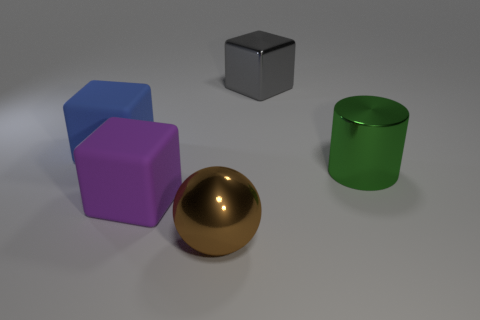Are there the same number of large purple matte things that are in front of the big brown metallic thing and large green shiny things?
Your response must be concise. No. Is there anything else that has the same material as the purple block?
Ensure brevity in your answer.  Yes. What number of small objects are either cyan rubber things or blocks?
Provide a short and direct response. 0. Do the large cube that is on the right side of the large purple matte thing and the cylinder have the same material?
Your answer should be very brief. Yes. Are there the same number of large gray cylinders and cylinders?
Your response must be concise. No. What is the material of the block in front of the big metal object to the right of the gray cube?
Your answer should be compact. Rubber. What number of green metallic objects have the same shape as the blue matte object?
Provide a succinct answer. 0. There is a matte block that is behind the metal thing to the right of the large cube that is to the right of the brown metal thing; what is its size?
Provide a succinct answer. Large. How many brown things are things or shiny cylinders?
Ensure brevity in your answer.  1. There is a object in front of the large purple matte object; is it the same shape as the big purple matte thing?
Provide a short and direct response. No. 